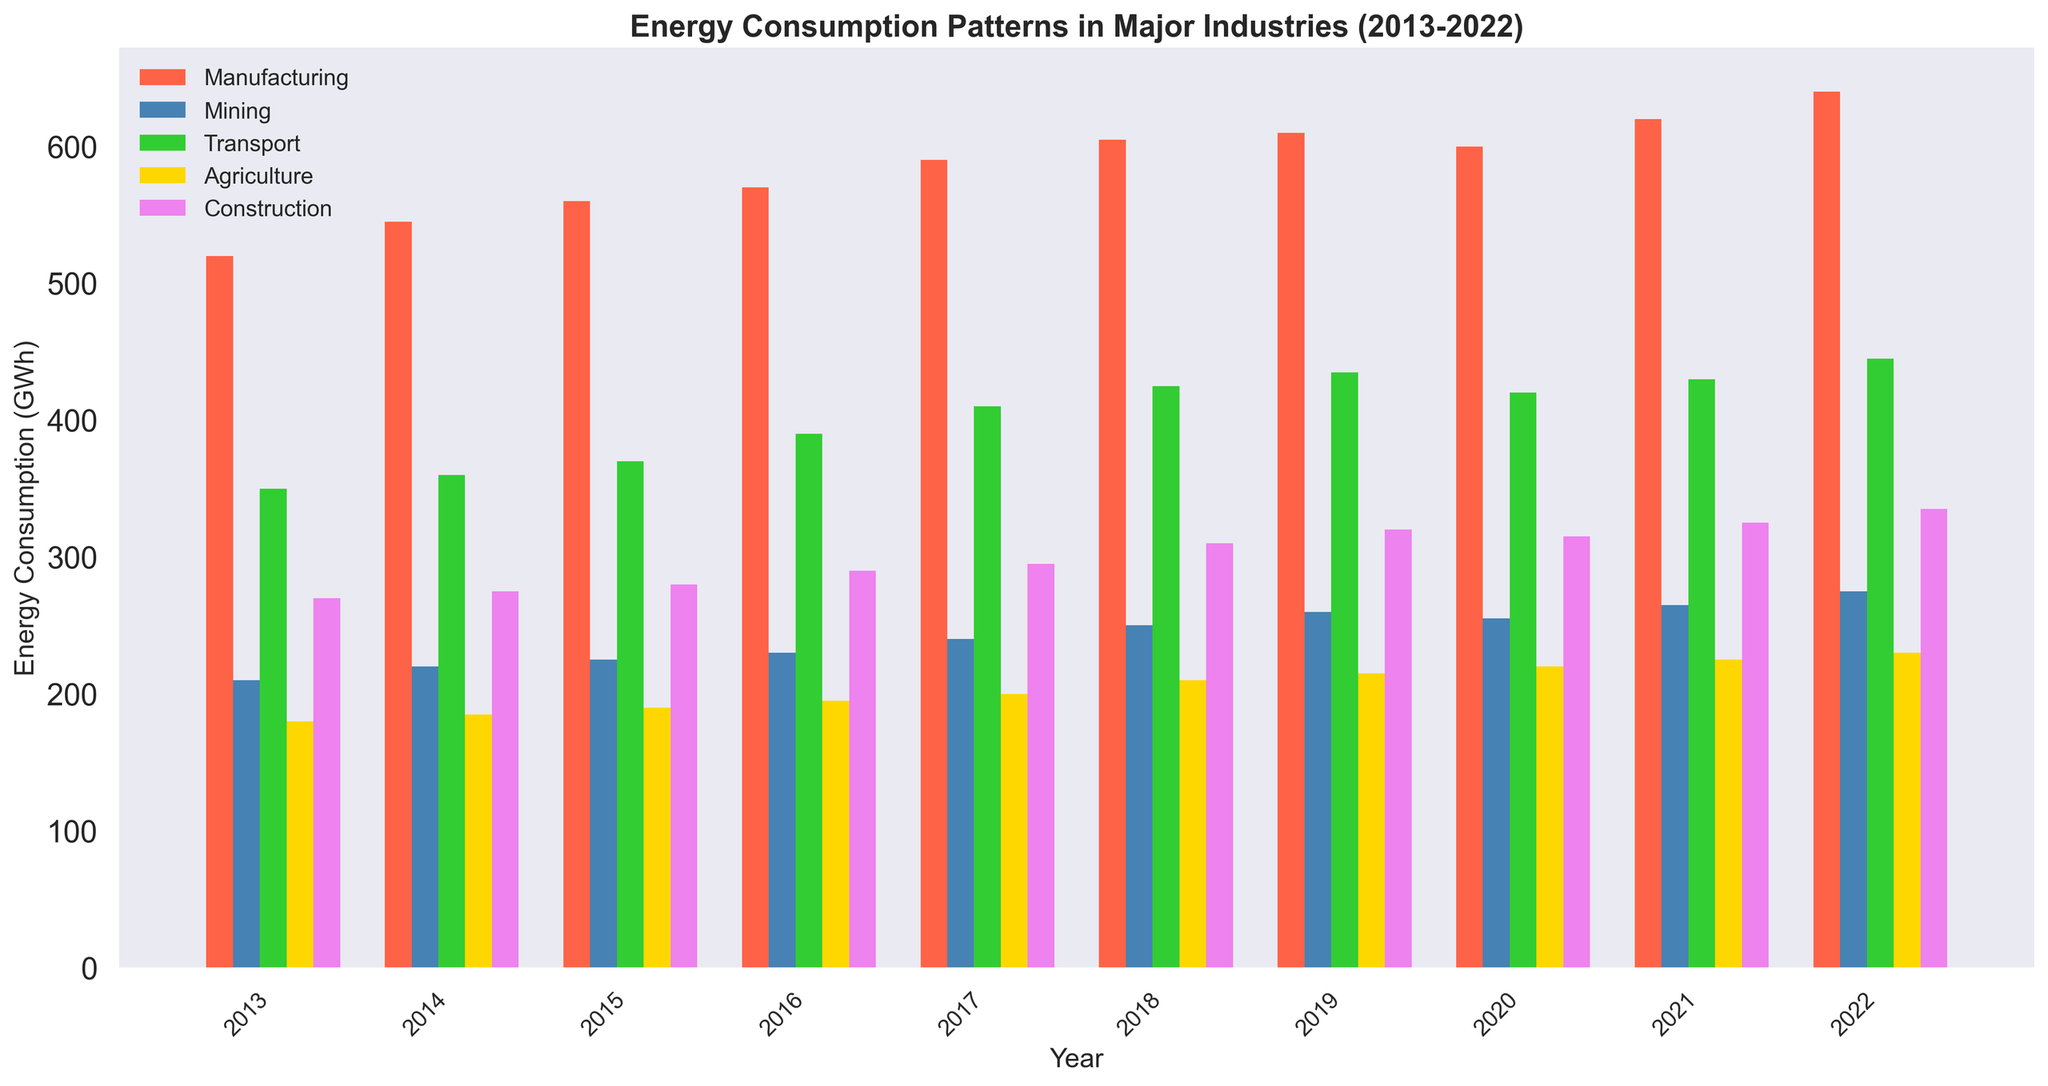Which industry had the highest energy consumption in 2022? By looking at the bar heights for 2022, the Manufacturing industry's bar is the tallest, indicating the highest consumption.
Answer: Manufacturing How did the energy consumption trend in the Transport industry change from 2013 to 2022? Observe the bar heights for Transport across the years: 2013 (350), 2014 (360), 2015 (370), 2016 (390), 2017 (410), 2018 (425), 2019 (435), 2020 (420), 2021 (430), 2022 (445). There is a generally increasing trend with a slight dip from 2019 to 2020.
Answer: Increasing with a dip in 2020 Which industry showed the smallest increase in energy consumption from 2013 to 2022? Calculate the difference in energy consumption between 2013 and 2022 for all industries: Manufacturing (640-520=120), Mining (275-210=65), Transport (445-350=95), Agriculture (230-180=50), Construction (335-270=65). The Agriculture industry has the smallest increase of 50 GWh.
Answer: Agriculture What is the total energy consumption for all industries combined in 2019? Add the energy consumption for each industry in 2019: Manufacturing (610), Mining (260), Transport (435), Agriculture (215), Construction (320). Total is 610 + 260 + 435 + 215 + 320 = 1840 GWh.
Answer: 1840 GWh In which year did the Construction industry experience a decrease in energy consumption compared to the previous year? Examine each year's bar for Construction: 2019 to 2020 shows a decrease from 320 to 315.
Answer: 2020 Which industry had the most consistent increase in energy consumption over the decade? Compare the bar heights and increments year by year for all industries. The Agriculture industry shows a consistent yearly increase without any decrease or plateau.
Answer: Agriculture By how much did the Manufacturing industry's energy consumption increase from 2015 to 2022? Subtract the energy consumption in 2015 from that in 2022 for Manufacturing: 640 - 560 = 80 GWh.
Answer: 80 GWh What is the average energy consumption of the Mining industry from 2013 to 2022? Sum the Mining consumption values from 2013 to 2022: 210 + 220 + 225 + 230 + 240 + 250 + 260 + 255 + 265 + 275 = 2430 GWh. Divide by the number of years: 2430 / 10 = 243 GWh.
Answer: 243 GWh Compare the energy consumption between Manufacturing and Transport industries in 2016. Which is greater and by how much? The Manufacturing consumption in 2016 is 570 GWh, while Transport is 390 GWh. The difference is 570 - 390 = 180 GWh. Manufacturing has higher consumption by 180 GWh.
Answer: Manufacturing by 180 GWh 